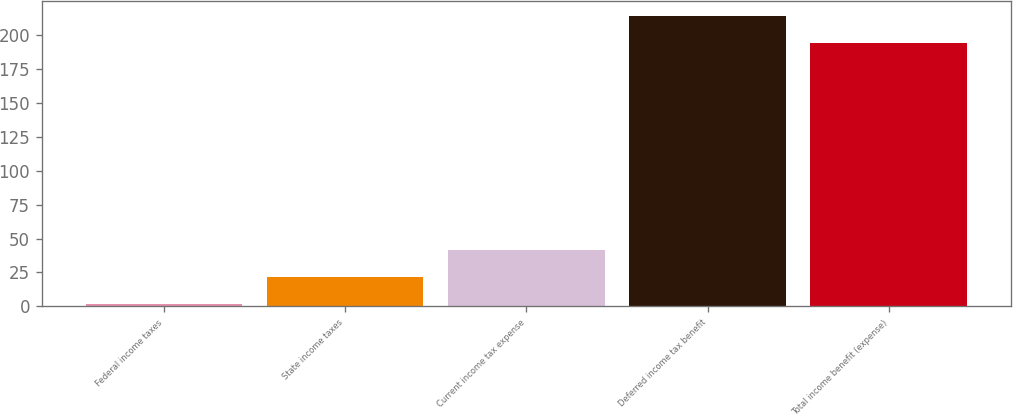<chart> <loc_0><loc_0><loc_500><loc_500><bar_chart><fcel>Federal income taxes<fcel>State income taxes<fcel>Current income tax expense<fcel>Deferred income tax benefit<fcel>Total income benefit (expense)<nl><fcel>2<fcel>21.8<fcel>41.6<fcel>213.8<fcel>194<nl></chart> 